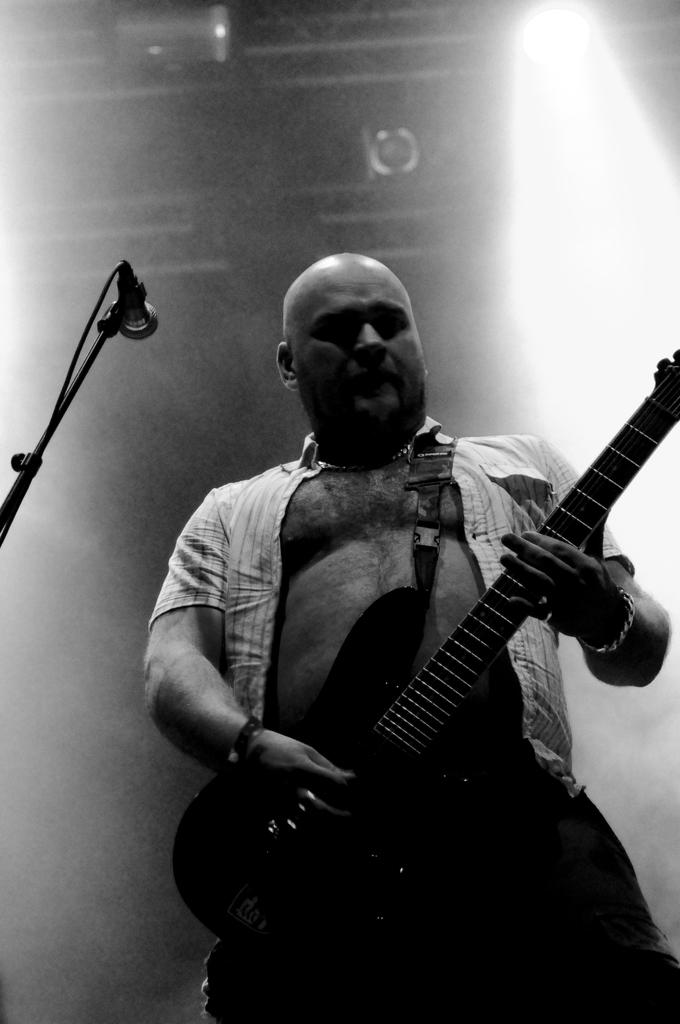What is the main subject of the image? There is a man in the image. What is the man doing in the image? The man is standing in the image. What object is the man holding in his hand? The man is holding a guitar in his hand. What can be seen on the left side of the image? There is a microphone on the left side of the image. What is visible in the background of the image? There is a wall in the background of the image. What type of animal can be seen walking on the sidewalk in the image? There is no sidewalk or animal present in the image. 